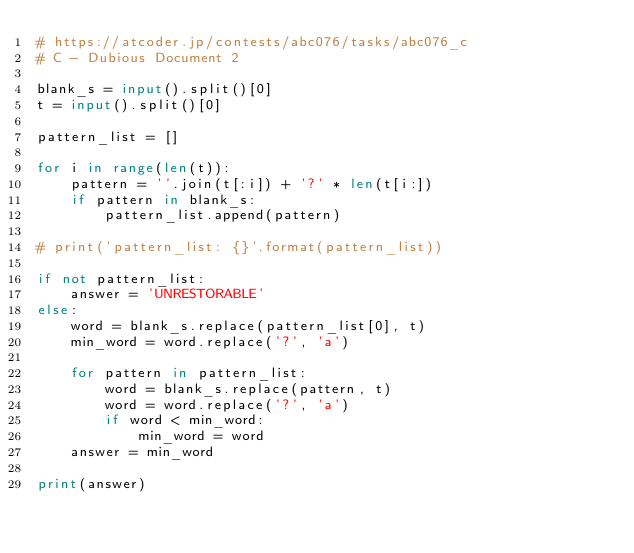<code> <loc_0><loc_0><loc_500><loc_500><_Python_># https://atcoder.jp/contests/abc076/tasks/abc076_c
# C - Dubious Document 2

blank_s = input().split()[0]
t = input().split()[0]

pattern_list = []

for i in range(len(t)):
    pattern = ''.join(t[:i]) + '?' * len(t[i:])
    if pattern in blank_s:
        pattern_list.append(pattern)

# print('pattern_list: {}'.format(pattern_list))

if not pattern_list:
    answer = 'UNRESTORABLE'
else:
    word = blank_s.replace(pattern_list[0], t)
    min_word = word.replace('?', 'a')
    
    for pattern in pattern_list:
        word = blank_s.replace(pattern, t)
        word = word.replace('?', 'a')
        if word < min_word:
            min_word = word
    answer = min_word

print(answer)</code> 